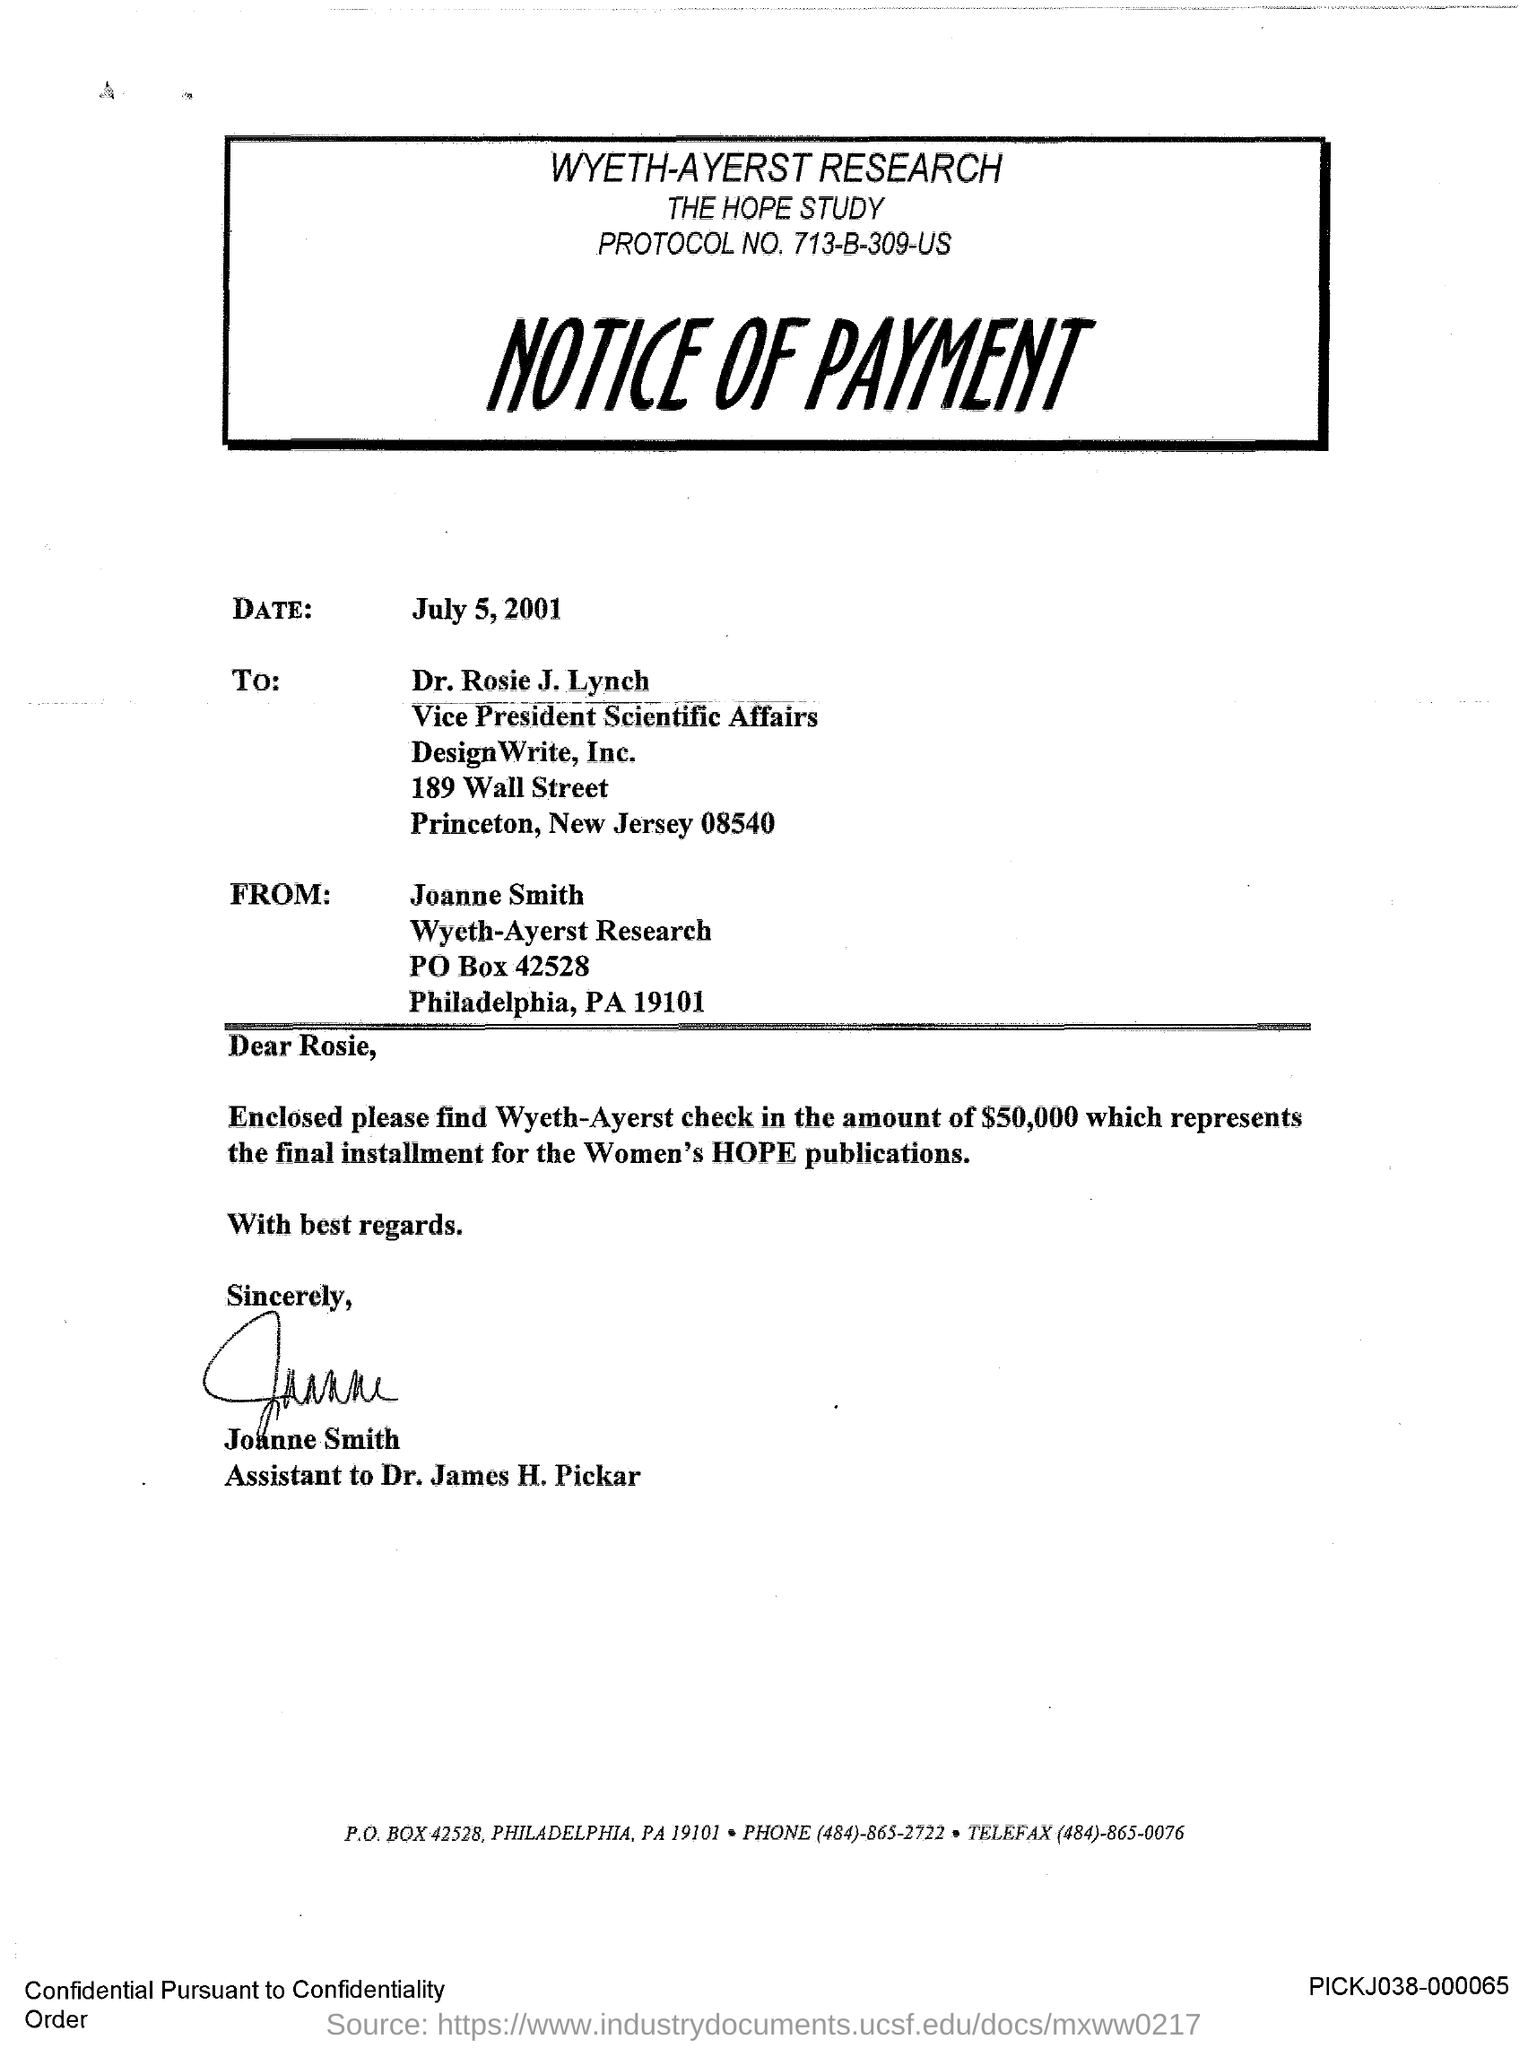Give some essential details in this illustration. The salutation of the letter is "Dear Rosie. The notice is a declaration that refers to a payment. The date is July 5, 2001. 